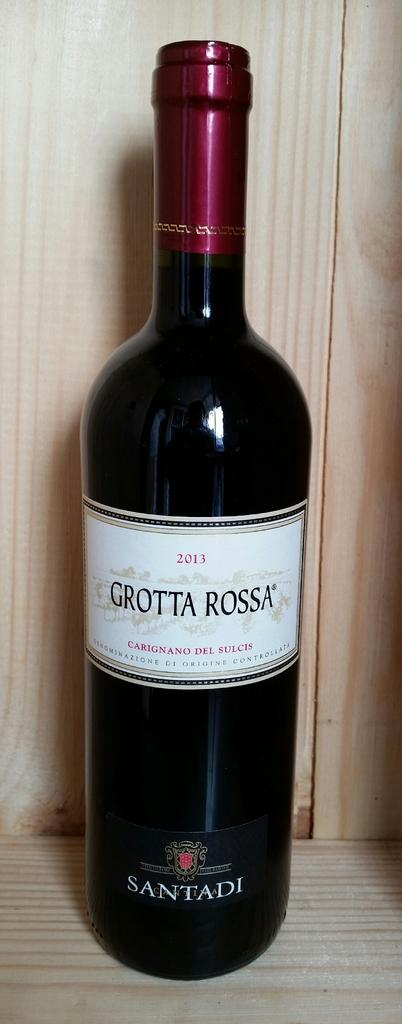<image>
Give a short and clear explanation of the subsequent image. A bottle of Grotta Rossa wine is sitting on a table. 